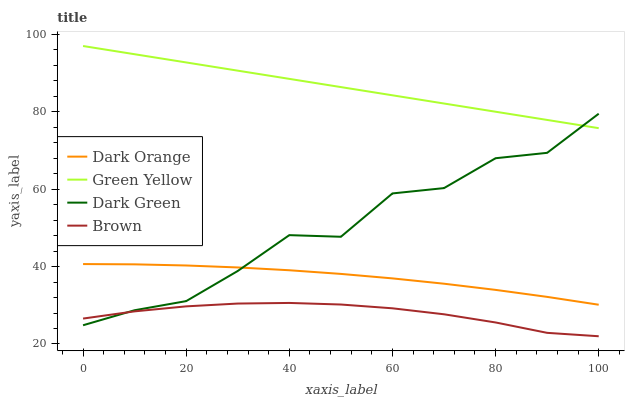Does Brown have the minimum area under the curve?
Answer yes or no. Yes. Does Green Yellow have the minimum area under the curve?
Answer yes or no. No. Does Brown have the maximum area under the curve?
Answer yes or no. No. Is Green Yellow the smoothest?
Answer yes or no. Yes. Is Dark Green the roughest?
Answer yes or no. Yes. Is Brown the smoothest?
Answer yes or no. No. Is Brown the roughest?
Answer yes or no. No. Does Green Yellow have the lowest value?
Answer yes or no. No. Does Brown have the highest value?
Answer yes or no. No. Is Brown less than Dark Orange?
Answer yes or no. Yes. Is Green Yellow greater than Dark Orange?
Answer yes or no. Yes. Does Brown intersect Dark Orange?
Answer yes or no. No. 